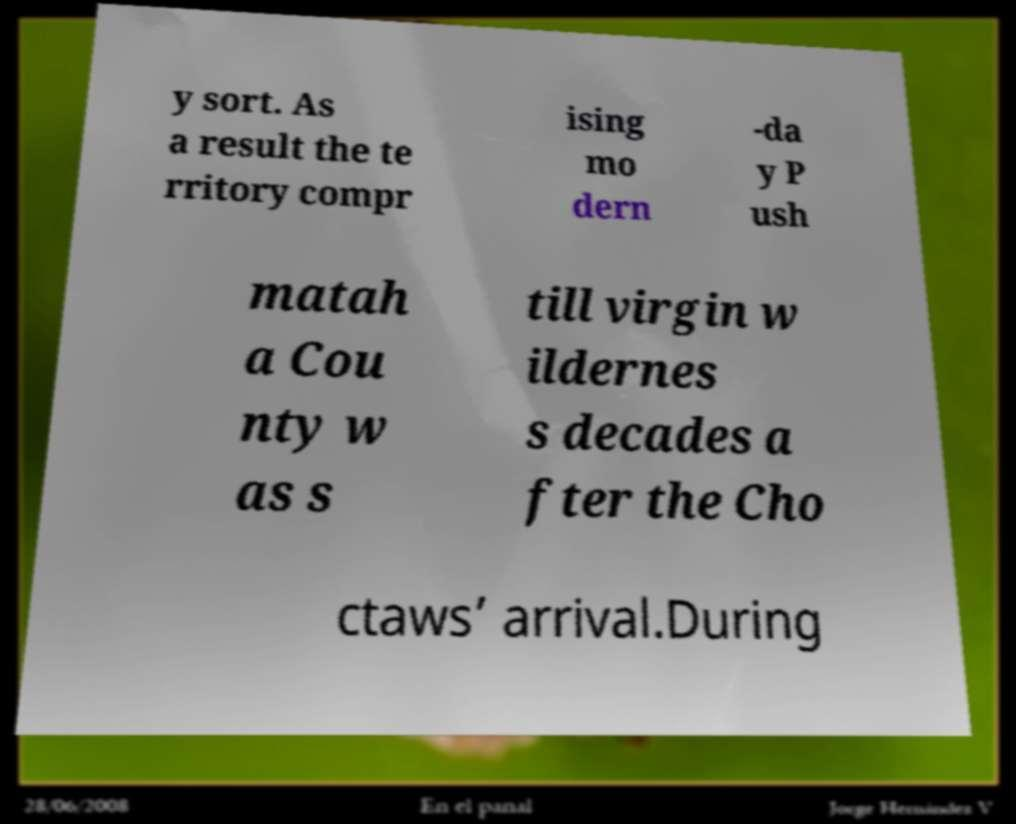Could you extract and type out the text from this image? y sort. As a result the te rritory compr ising mo dern -da y P ush matah a Cou nty w as s till virgin w ildernes s decades a fter the Cho ctaws’ arrival.During 